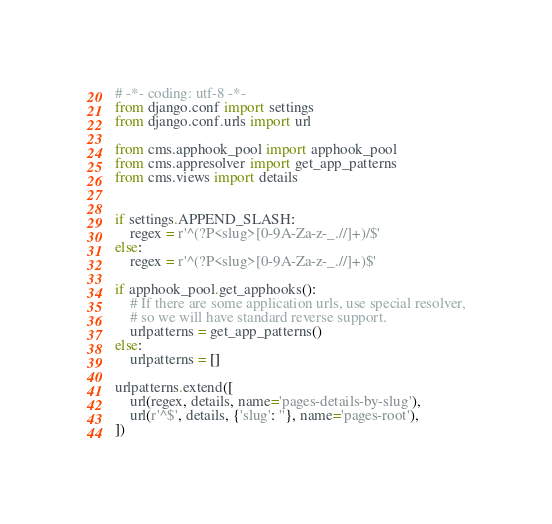Convert code to text. <code><loc_0><loc_0><loc_500><loc_500><_Python_># -*- coding: utf-8 -*-
from django.conf import settings
from django.conf.urls import url

from cms.apphook_pool import apphook_pool
from cms.appresolver import get_app_patterns
from cms.views import details


if settings.APPEND_SLASH:
    regex = r'^(?P<slug>[0-9A-Za-z-_.//]+)/$'
else:
    regex = r'^(?P<slug>[0-9A-Za-z-_.//]+)$'

if apphook_pool.get_apphooks():
    # If there are some application urls, use special resolver,
    # so we will have standard reverse support.
    urlpatterns = get_app_patterns()
else:
    urlpatterns = []

urlpatterns.extend([
    url(regex, details, name='pages-details-by-slug'),
    url(r'^$', details, {'slug': ''}, name='pages-root'),
])
</code> 